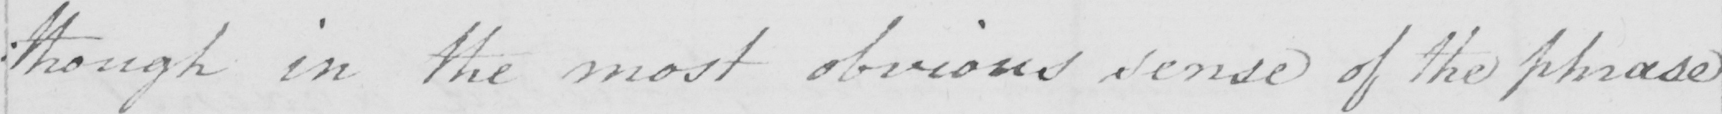What does this handwritten line say? : though in the most obvious sense of the phrase 